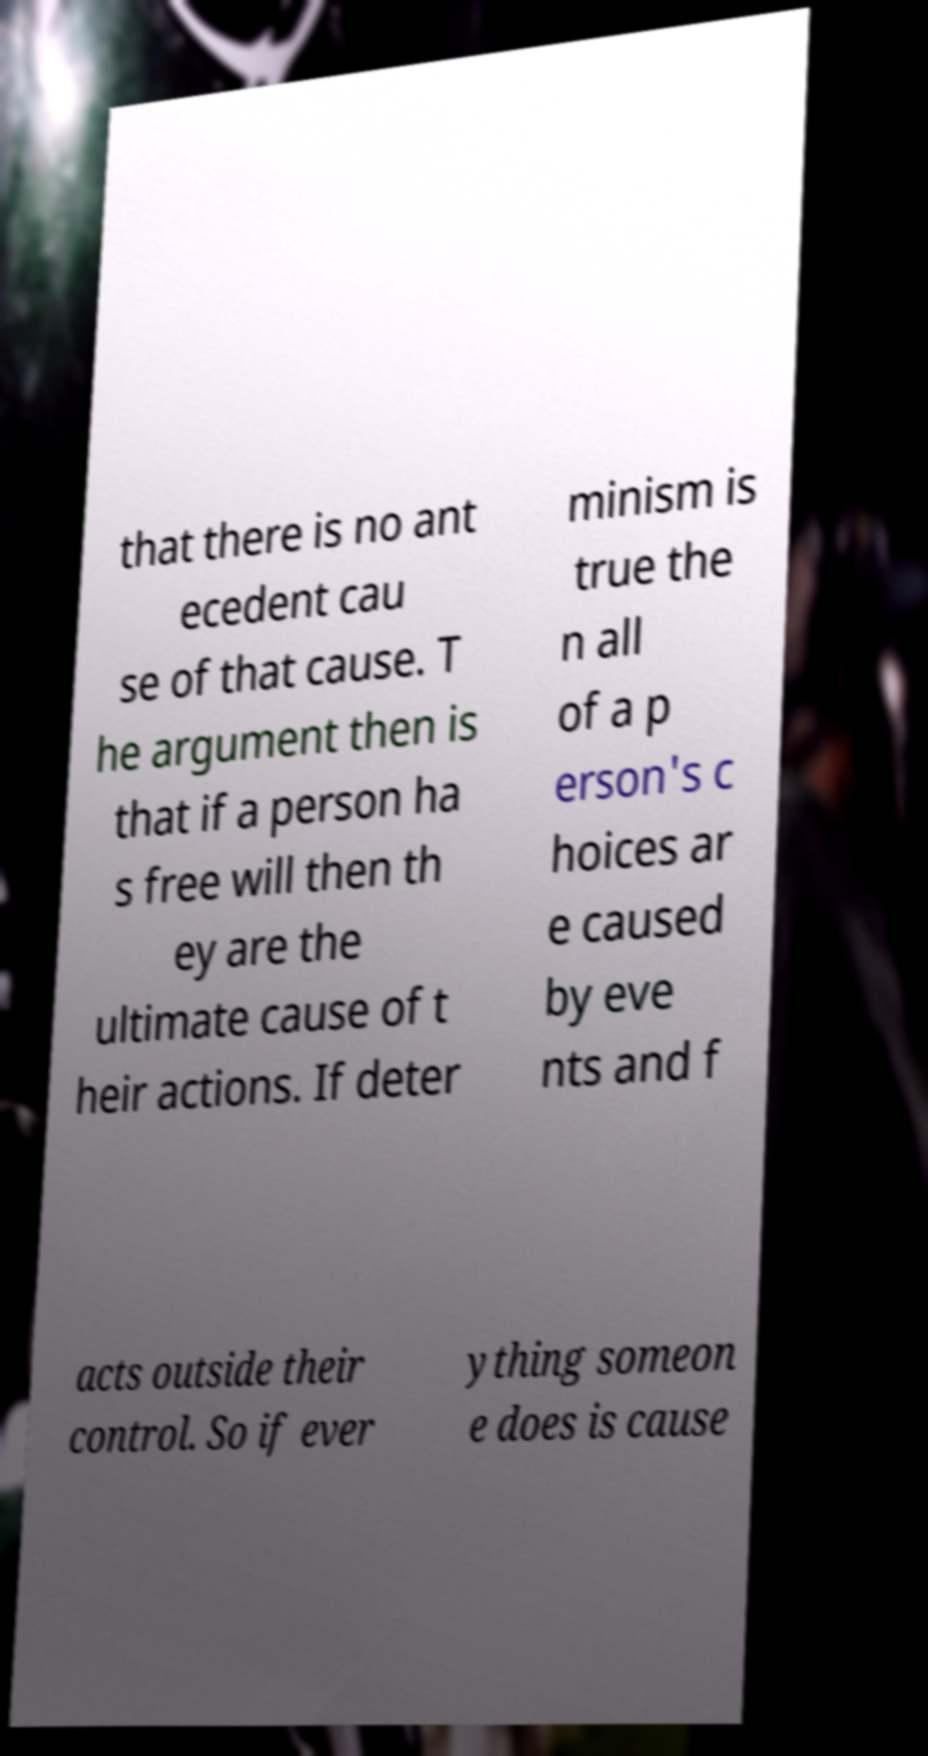For documentation purposes, I need the text within this image transcribed. Could you provide that? that there is no ant ecedent cau se of that cause. T he argument then is that if a person ha s free will then th ey are the ultimate cause of t heir actions. If deter minism is true the n all of a p erson's c hoices ar e caused by eve nts and f acts outside their control. So if ever ything someon e does is cause 